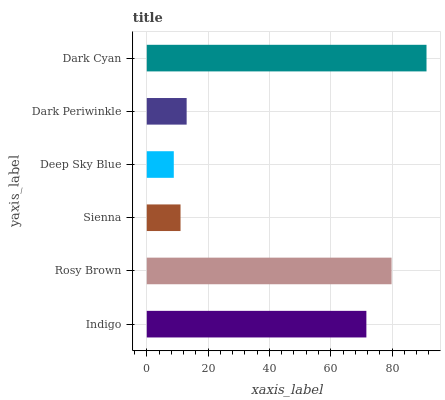Is Deep Sky Blue the minimum?
Answer yes or no. Yes. Is Dark Cyan the maximum?
Answer yes or no. Yes. Is Rosy Brown the minimum?
Answer yes or no. No. Is Rosy Brown the maximum?
Answer yes or no. No. Is Rosy Brown greater than Indigo?
Answer yes or no. Yes. Is Indigo less than Rosy Brown?
Answer yes or no. Yes. Is Indigo greater than Rosy Brown?
Answer yes or no. No. Is Rosy Brown less than Indigo?
Answer yes or no. No. Is Indigo the high median?
Answer yes or no. Yes. Is Dark Periwinkle the low median?
Answer yes or no. Yes. Is Rosy Brown the high median?
Answer yes or no. No. Is Rosy Brown the low median?
Answer yes or no. No. 